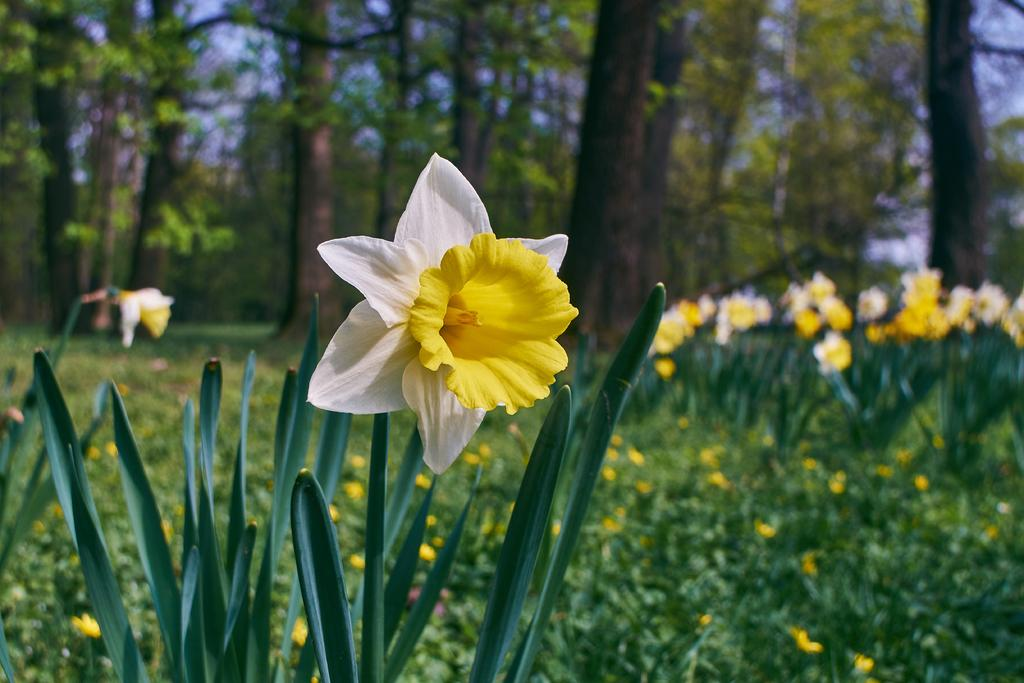What type of vegetation is at the bottom of the image? There are plants at the bottom of the image. What feature do the plants have? The plants have flowers. What colors are the flowers? The flowers are in yellow and white colors. What can be seen in the background of the image? There are many trees in the background of the image. How many ants can be seen crawling on the flowers in the image? There are no ants visible in the image; it only shows plants with flowers and trees in the background. 